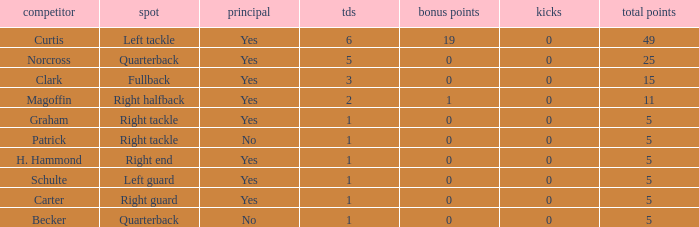Name the most touchdowns for becker  1.0. 